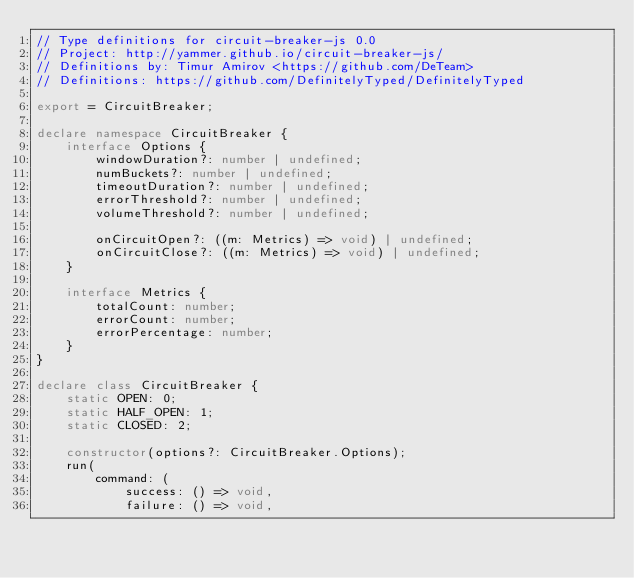<code> <loc_0><loc_0><loc_500><loc_500><_TypeScript_>// Type definitions for circuit-breaker-js 0.0
// Project: http://yammer.github.io/circuit-breaker-js/
// Definitions by: Timur Amirov <https://github.com/DeTeam>
// Definitions: https://github.com/DefinitelyTyped/DefinitelyTyped

export = CircuitBreaker;

declare namespace CircuitBreaker {
    interface Options {
        windowDuration?: number | undefined;
        numBuckets?: number | undefined;
        timeoutDuration?: number | undefined;
        errorThreshold?: number | undefined;
        volumeThreshold?: number | undefined;

        onCircuitOpen?: ((m: Metrics) => void) | undefined;
        onCircuitClose?: ((m: Metrics) => void) | undefined;
    }

    interface Metrics {
        totalCount: number;
        errorCount: number;
        errorPercentage: number;
    }
}

declare class CircuitBreaker {
    static OPEN: 0;
    static HALF_OPEN: 1;
    static CLOSED: 2;

    constructor(options?: CircuitBreaker.Options);
    run(
        command: (
            success: () => void,
            failure: () => void,</code> 